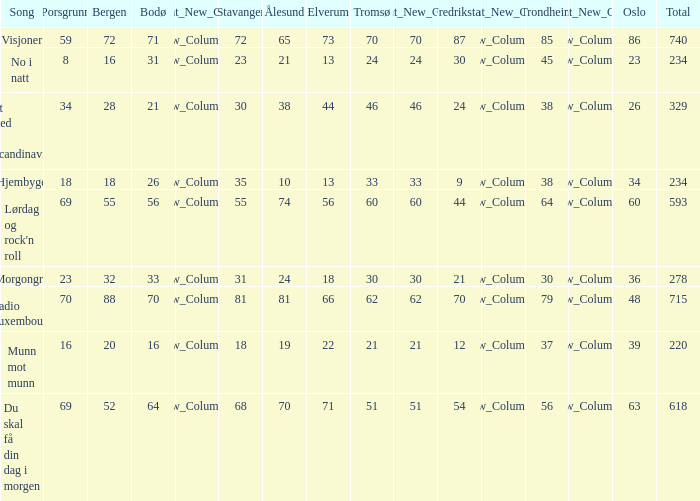In scandinavia, what is the count of elverum for a specific site? 1.0. 